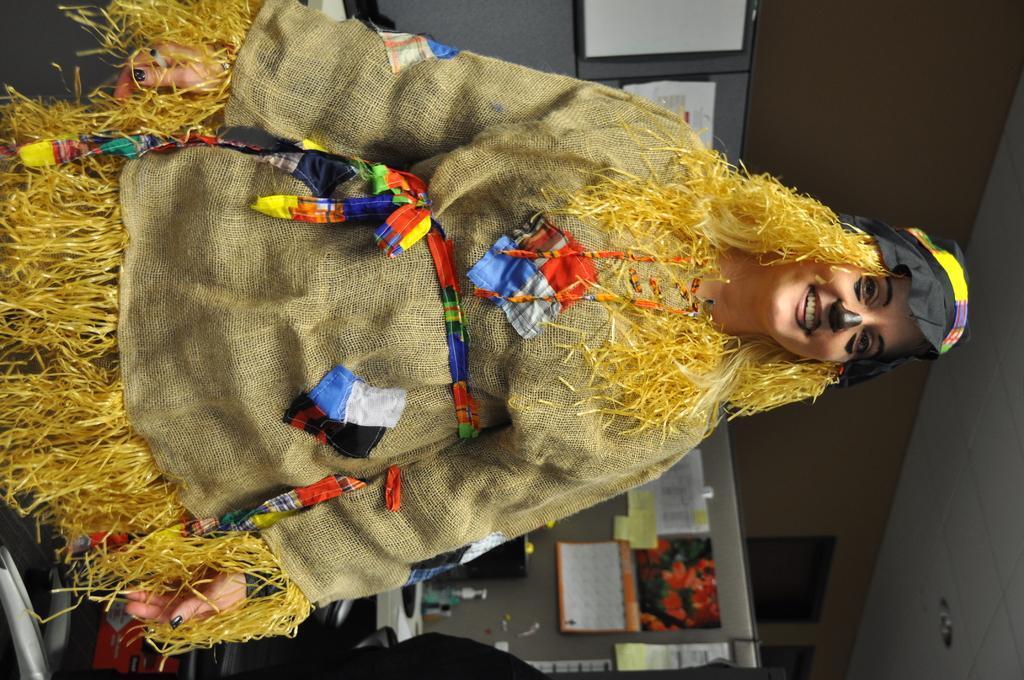In one or two sentences, can you explain what this image depicts? In this picture I can see a woman in front who is standing and I see that she is wearing a costume and she is smiling. In the background I see desks on which there are few papers and other things and I see the wall and the ceiling. 